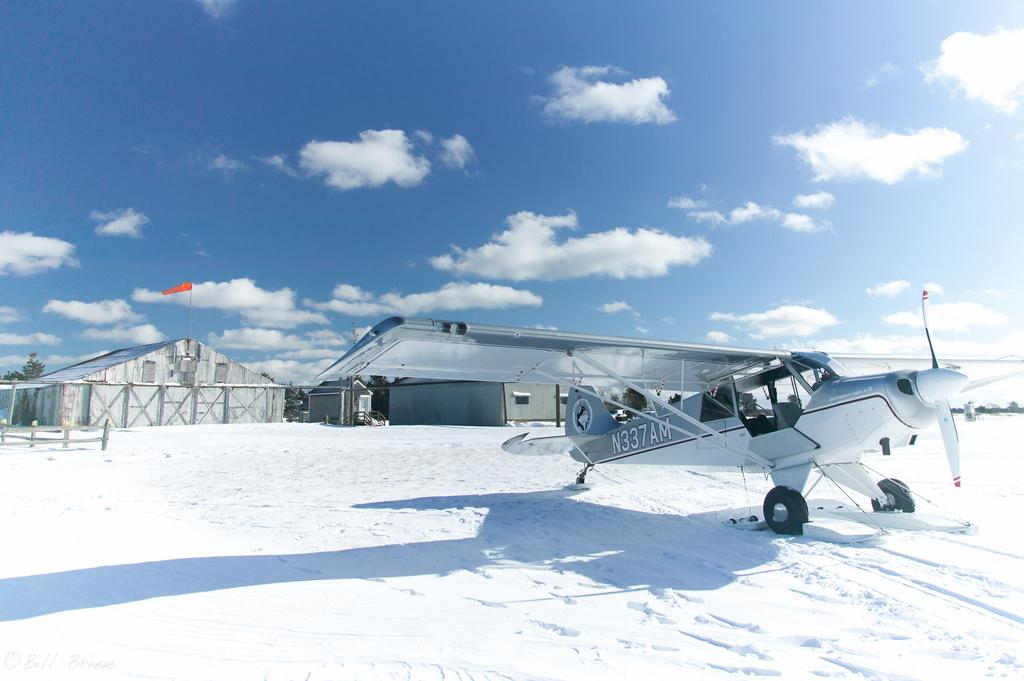<image>
Relay a brief, clear account of the picture shown. a snowy scene with a plane N337AM on the snow covered runway 